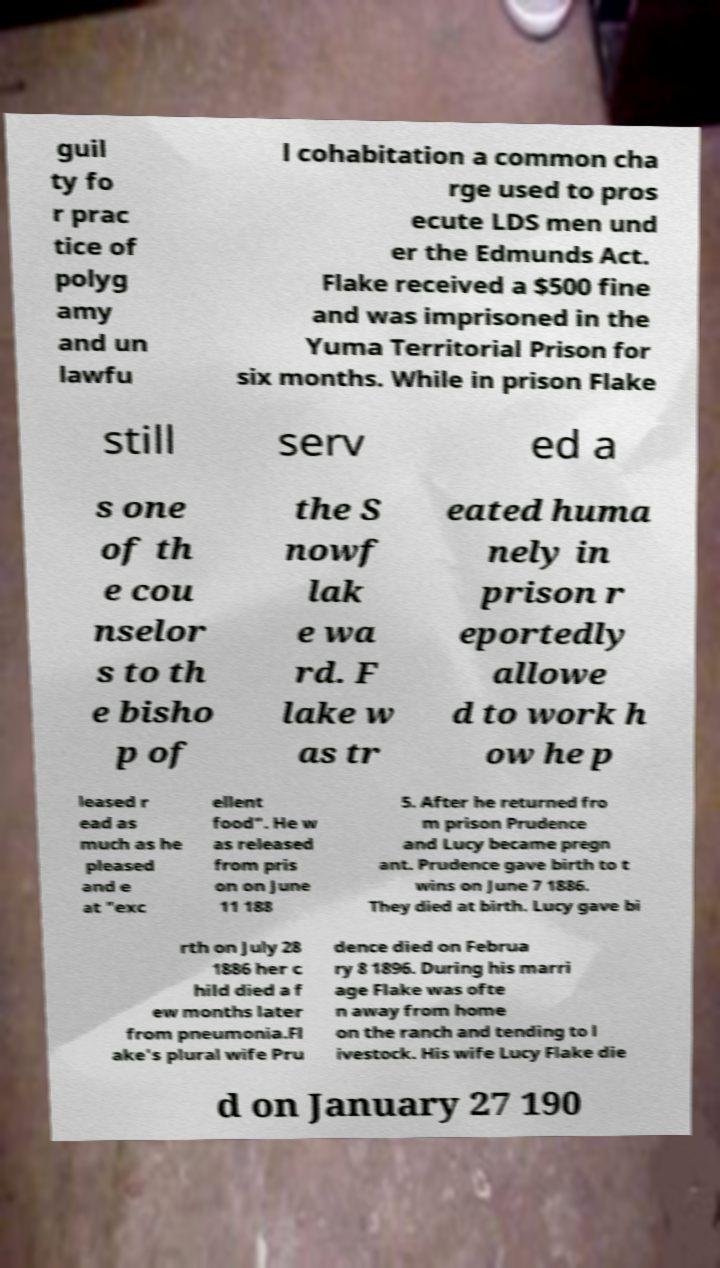Can you accurately transcribe the text from the provided image for me? guil ty fo r prac tice of polyg amy and un lawfu l cohabitation a common cha rge used to pros ecute LDS men und er the Edmunds Act. Flake received a $500 fine and was imprisoned in the Yuma Territorial Prison for six months. While in prison Flake still serv ed a s one of th e cou nselor s to th e bisho p of the S nowf lak e wa rd. F lake w as tr eated huma nely in prison r eportedly allowe d to work h ow he p leased r ead as much as he pleased and e at "exc ellent food". He w as released from pris on on June 11 188 5. After he returned fro m prison Prudence and Lucy became pregn ant. Prudence gave birth to t wins on June 7 1886. They died at birth. Lucy gave bi rth on July 28 1886 her c hild died a f ew months later from pneumonia.Fl ake's plural wife Pru dence died on Februa ry 8 1896. During his marri age Flake was ofte n away from home on the ranch and tending to l ivestock. His wife Lucy Flake die d on January 27 190 